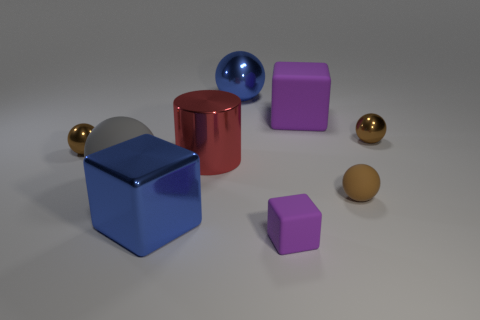Subtract all brown balls. How many were subtracted if there are1brown balls left? 2 Subtract all brown cylinders. How many brown spheres are left? 3 Add 1 purple things. How many objects exist? 10 Subtract all cubes. How many objects are left? 6 Add 2 tiny gray metal cylinders. How many tiny gray metal cylinders exist? 2 Subtract 0 gray cubes. How many objects are left? 9 Subtract all big blue metal objects. Subtract all brown rubber balls. How many objects are left? 6 Add 3 tiny rubber cubes. How many tiny rubber cubes are left? 4 